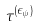<formula> <loc_0><loc_0><loc_500><loc_500>\tau ^ { ( \epsilon _ { \psi } ) }</formula> 